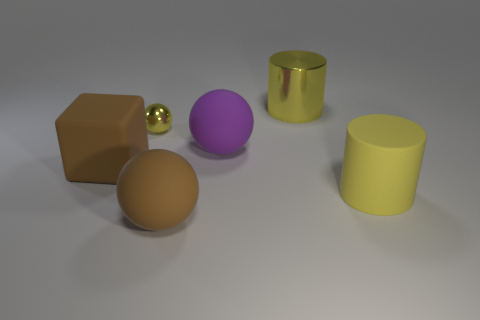Are the cylinder that is behind the large yellow matte thing and the big brown thing to the left of the tiny yellow metallic sphere made of the same material?
Your answer should be compact. No. There is a large rubber block; are there any small yellow metal objects behind it?
Give a very brief answer. Yes. How many brown things are rubber spheres or blocks?
Your answer should be compact. 2. Does the small ball have the same material as the brown object in front of the big brown matte block?
Provide a short and direct response. No. What size is the other yellow thing that is the same shape as the big yellow matte thing?
Keep it short and to the point. Large. What material is the big block?
Your response must be concise. Rubber. What is the large sphere in front of the large ball behind the thing that is to the right of the large metallic cylinder made of?
Offer a terse response. Rubber. Do the matte object that is to the left of the tiny object and the brown thing on the right side of the tiny metallic sphere have the same size?
Provide a succinct answer. Yes. How many other objects are the same material as the small object?
Your response must be concise. 1. What number of shiny objects are large brown cubes or big spheres?
Your answer should be very brief. 0. 